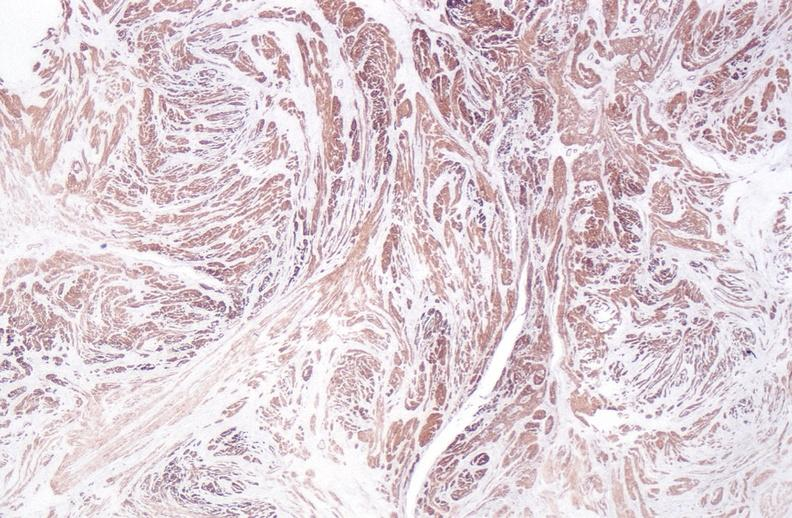do no tissue recognizable as ovary stain?
Answer the question using a single word or phrase. No 